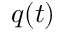Convert formula to latex. <formula><loc_0><loc_0><loc_500><loc_500>q ( t )</formula> 